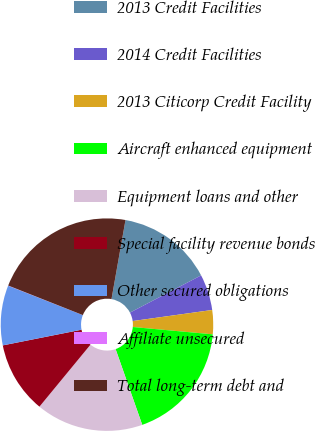Convert chart to OTSL. <chart><loc_0><loc_0><loc_500><loc_500><pie_chart><fcel>2013 Credit Facilities<fcel>2014 Credit Facilities<fcel>2013 Citicorp Credit Facility<fcel>Aircraft enhanced equipment<fcel>Equipment loans and other<fcel>Special facility revenue bonds<fcel>Other secured obligations<fcel>Affiliate unsecured<fcel>Total long-term debt and<nl><fcel>14.54%<fcel>5.47%<fcel>3.66%<fcel>18.16%<fcel>16.35%<fcel>10.91%<fcel>9.1%<fcel>0.03%<fcel>21.79%<nl></chart> 